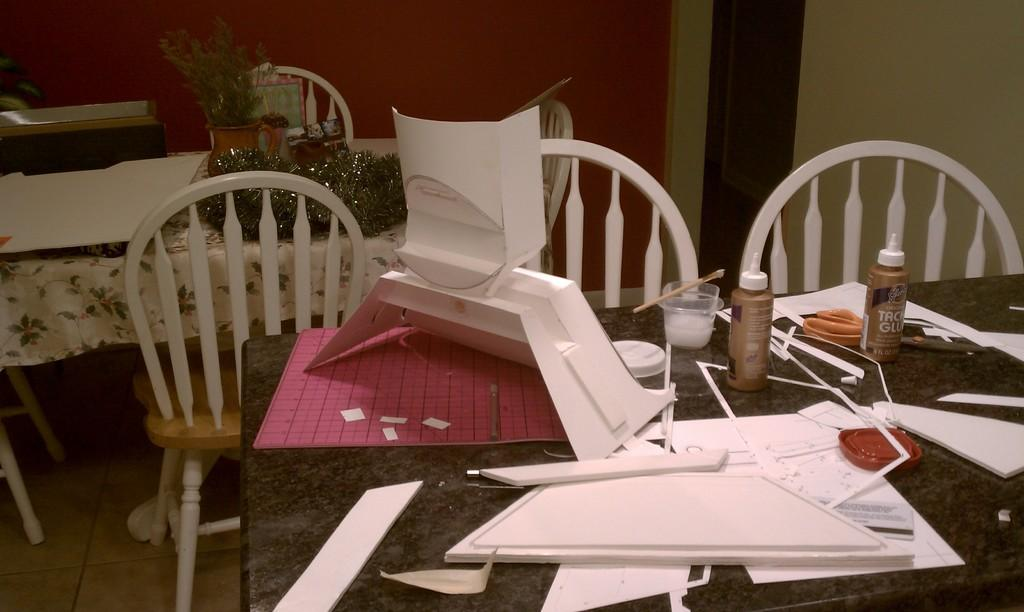What is on the table in the image? There is a lid, scissors, paper, and glue bottles on the table. What else can be seen on the table? There are objects on the table. Are there any chairs beside the table? Yes, there are chairs beside the table. What is on another table in the image? There is a plant and objects on the other table. What color is the wall in the image? The wall is painted red. What type of heart can be seen beating in the image? There is no heart visible in the image. How can you tell if the plant on the other table is quiet? Plants do not make noise or exhibit the quality of being quiet; they are inanimate objects. 